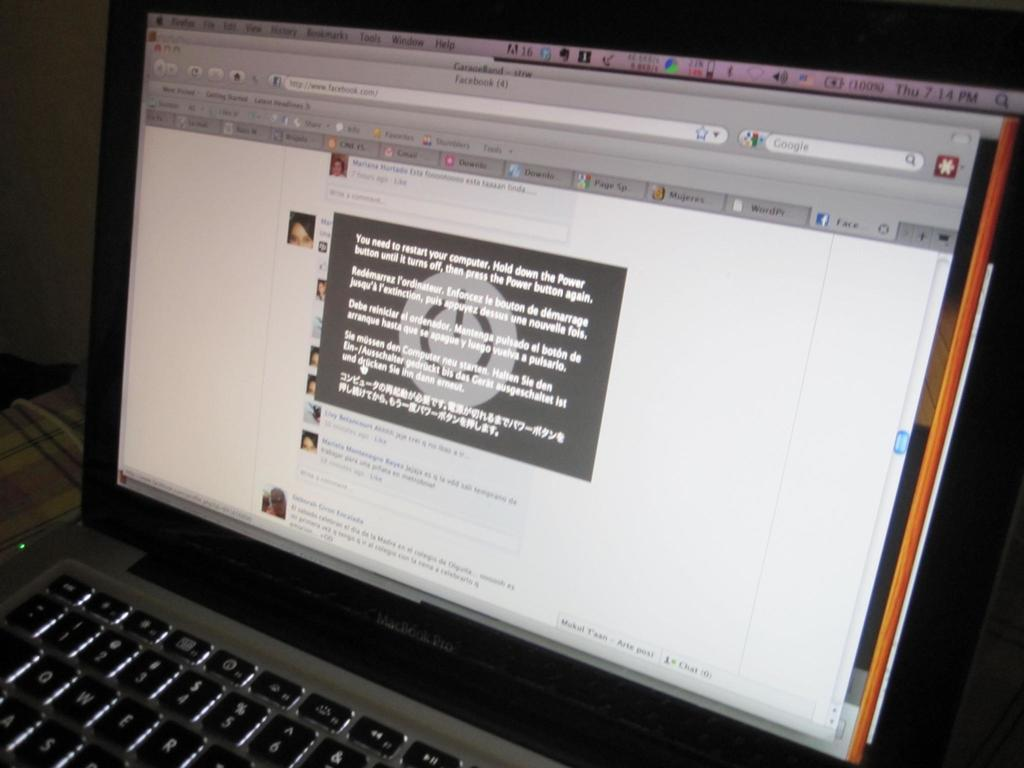<image>
Summarize the visual content of the image. A message on the computer monitor says to restart. 